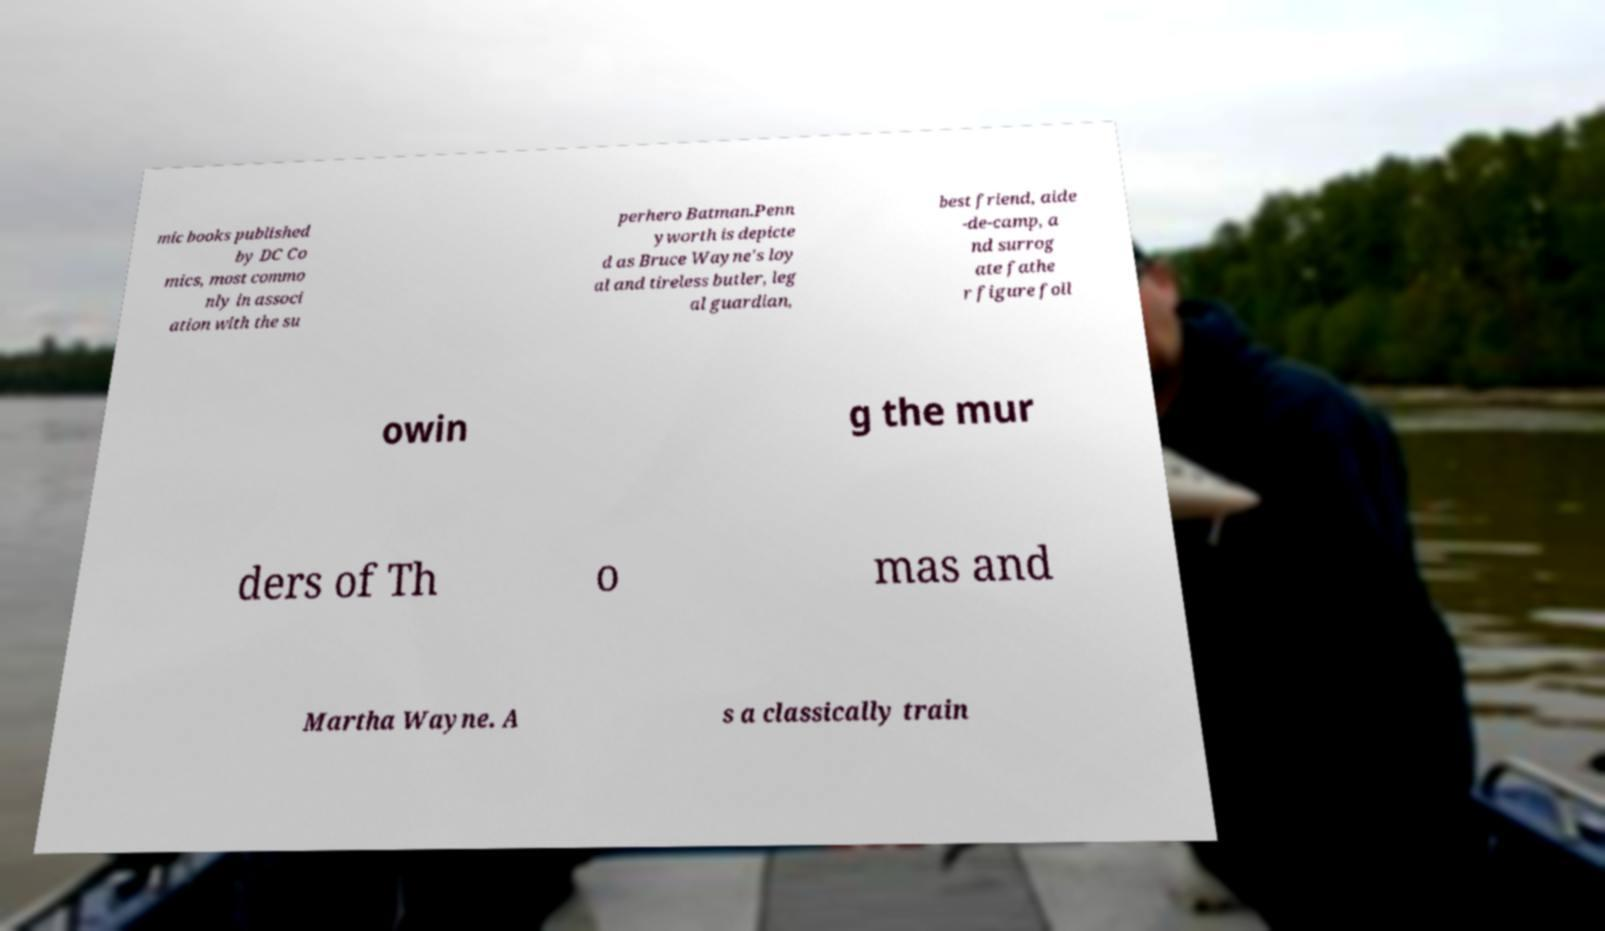Could you extract and type out the text from this image? mic books published by DC Co mics, most commo nly in associ ation with the su perhero Batman.Penn yworth is depicte d as Bruce Wayne's loy al and tireless butler, leg al guardian, best friend, aide -de-camp, a nd surrog ate fathe r figure foll owin g the mur ders of Th o mas and Martha Wayne. A s a classically train 